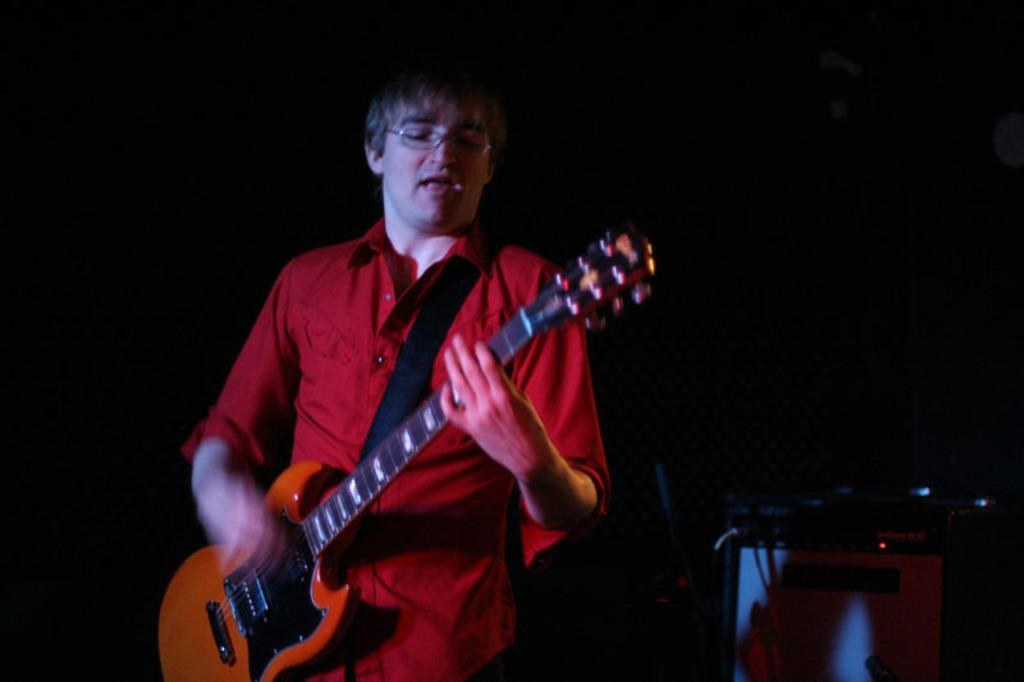Who is the main subject in the image? There is a man in the image. What is the man wearing? The man is wearing a red shirt. What is the man doing in the image? The man is playing a guitar. Can you describe the object with wires in the image? There is an object with wires in the image, but it is not clear what it is. What is the color of the background in the image? The background of the image is black. How many eyes can be seen on the company logo in the image? There is no company logo present in the image, so it is not possible to determine the number of eyes on it. 